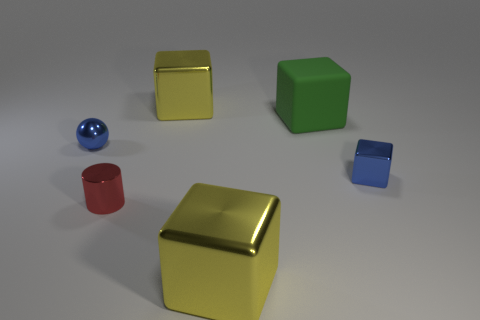What is the big thing that is on the left side of the large metallic object that is to the right of the big yellow block that is behind the matte block made of? The large object on the left side of the prominent metallic structure, which is situated to the right of the substantial yellow block and behind the matte block, appears to be made of metal. Specifically, its shiny surfaces and clean edges resemble those typically found on metal objects, suggesting an industrial or synthetic material rather than a natural one. 